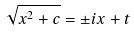Convert formula to latex. <formula><loc_0><loc_0><loc_500><loc_500>\sqrt { x ^ { 2 } + c } = \pm i x + t</formula> 